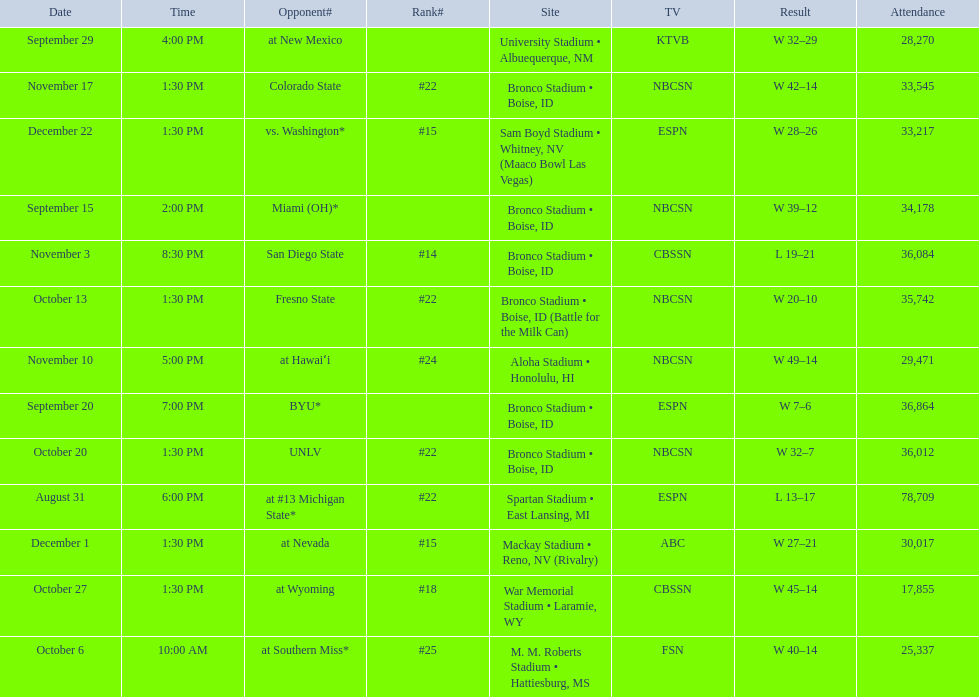Give me the full table as a dictionary. {'header': ['Date', 'Time', 'Opponent#', 'Rank#', 'Site', 'TV', 'Result', 'Attendance'], 'rows': [['September 29', '4:00 PM', 'at\xa0New Mexico', '', 'University Stadium • Albuequerque, NM', 'KTVB', 'W\xa032–29', '28,270'], ['November 17', '1:30 PM', 'Colorado State', '#22', 'Bronco Stadium • Boise, ID', 'NBCSN', 'W\xa042–14', '33,545'], ['December 22', '1:30 PM', 'vs.\xa0Washington*', '#15', 'Sam Boyd Stadium • Whitney, NV (Maaco Bowl Las Vegas)', 'ESPN', 'W\xa028–26', '33,217'], ['September 15', '2:00 PM', 'Miami (OH)*', '', 'Bronco Stadium • Boise, ID', 'NBCSN', 'W\xa039–12', '34,178'], ['November 3', '8:30 PM', 'San Diego State', '#14', 'Bronco Stadium • Boise, ID', 'CBSSN', 'L\xa019–21', '36,084'], ['October 13', '1:30 PM', 'Fresno State', '#22', 'Bronco Stadium • Boise, ID (Battle for the Milk Can)', 'NBCSN', 'W\xa020–10', '35,742'], ['November 10', '5:00 PM', 'at\xa0Hawaiʻi', '#24', 'Aloha Stadium • Honolulu, HI', 'NBCSN', 'W\xa049–14', '29,471'], ['September 20', '7:00 PM', 'BYU*', '', 'Bronco Stadium • Boise, ID', 'ESPN', 'W\xa07–6', '36,864'], ['October 20', '1:30 PM', 'UNLV', '#22', 'Bronco Stadium • Boise, ID', 'NBCSN', 'W\xa032–7', '36,012'], ['August 31', '6:00 PM', 'at\xa0#13\xa0Michigan State*', '#22', 'Spartan Stadium • East Lansing, MI', 'ESPN', 'L\xa013–17', '78,709'], ['December 1', '1:30 PM', 'at\xa0Nevada', '#15', 'Mackay Stadium • Reno, NV (Rivalry)', 'ABC', 'W\xa027–21', '30,017'], ['October 27', '1:30 PM', 'at\xa0Wyoming', '#18', 'War Memorial Stadium • Laramie, WY', 'CBSSN', 'W\xa045–14', '17,855'], ['October 6', '10:00 AM', 'at\xa0Southern Miss*', '#25', 'M. M. Roberts Stadium • Hattiesburg, MS', 'FSN', 'W\xa040–14', '25,337']]} What is the total number of games played at bronco stadium? 6. 